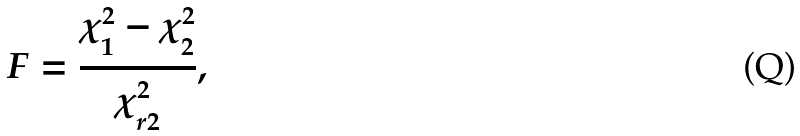<formula> <loc_0><loc_0><loc_500><loc_500>F = \frac { \chi ^ { 2 } _ { 1 } - \chi ^ { 2 } _ { 2 } } { \chi ^ { 2 } _ { r 2 } } ,</formula> 